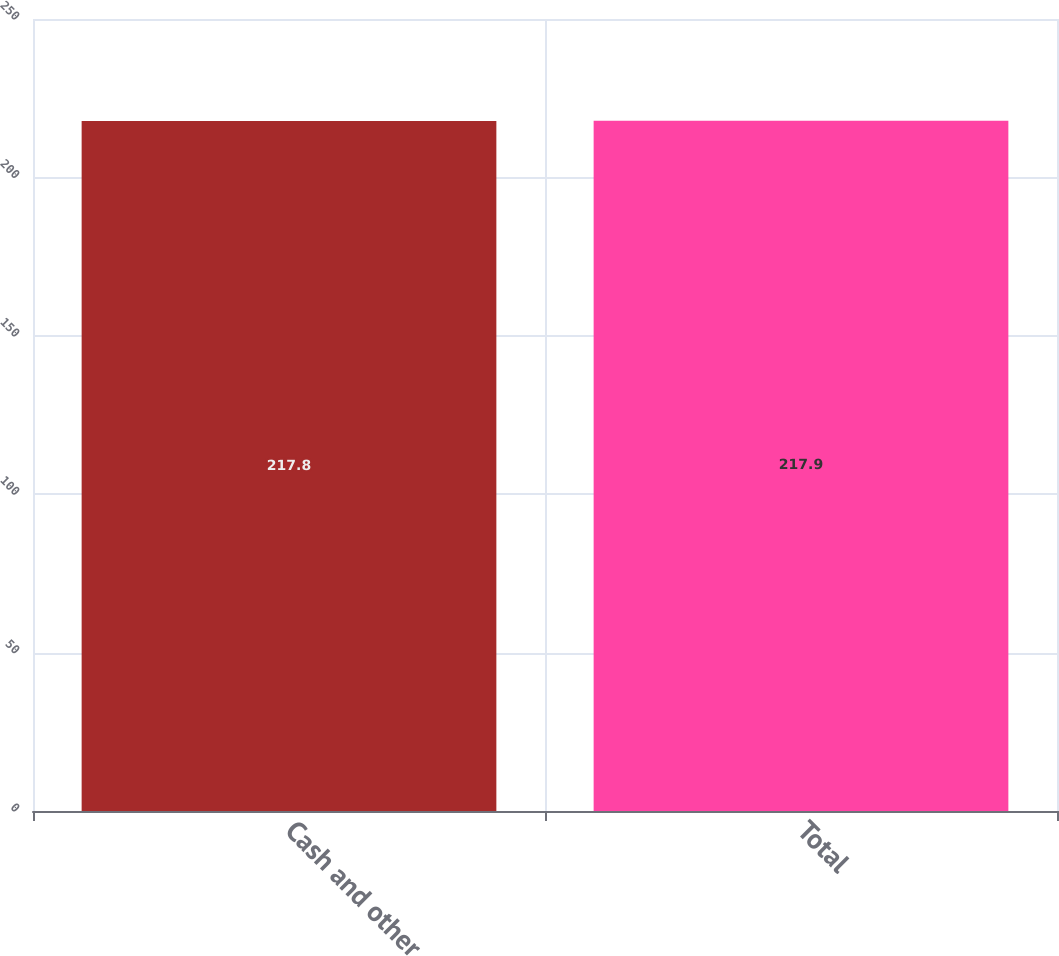Convert chart. <chart><loc_0><loc_0><loc_500><loc_500><bar_chart><fcel>Cash and other<fcel>Total<nl><fcel>217.8<fcel>217.9<nl></chart> 